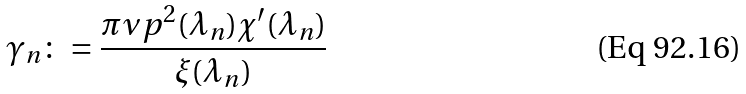Convert formula to latex. <formula><loc_0><loc_0><loc_500><loc_500>\gamma _ { n } \colon = \frac { \pi \nu p ^ { 2 } ( \lambda _ { n } ) \chi ^ { \prime } ( \lambda _ { n } ) } { \xi ( \lambda _ { n } ) }</formula> 